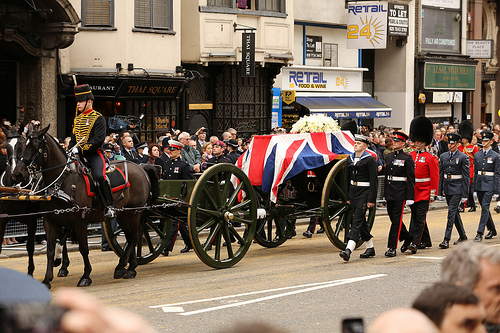What animal is it? The animal is a horse. 